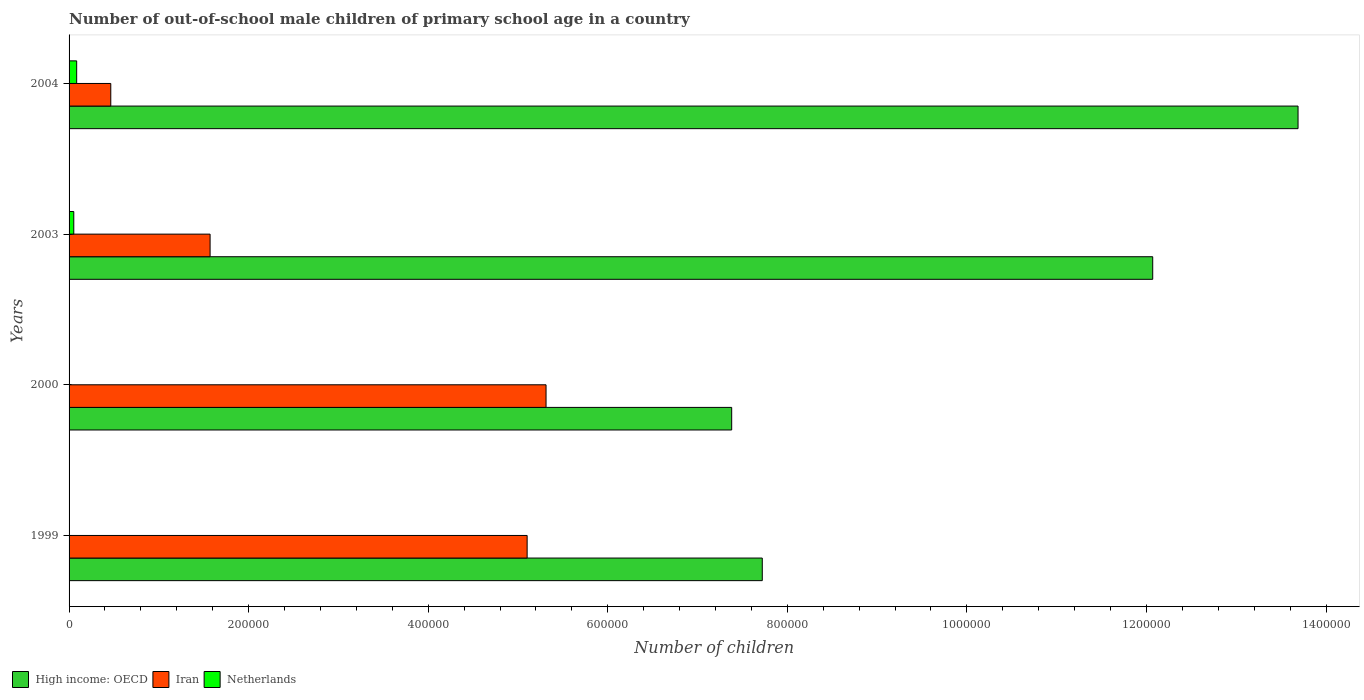How many different coloured bars are there?
Provide a succinct answer. 3. How many groups of bars are there?
Your response must be concise. 4. Are the number of bars per tick equal to the number of legend labels?
Ensure brevity in your answer.  Yes. How many bars are there on the 4th tick from the bottom?
Offer a very short reply. 3. In how many cases, is the number of bars for a given year not equal to the number of legend labels?
Make the answer very short. 0. What is the number of out-of-school male children in Iran in 2003?
Ensure brevity in your answer.  1.57e+05. Across all years, what is the maximum number of out-of-school male children in Netherlands?
Your response must be concise. 8467. What is the total number of out-of-school male children in High income: OECD in the graph?
Offer a terse response. 4.09e+06. What is the difference between the number of out-of-school male children in Netherlands in 1999 and that in 2003?
Provide a succinct answer. -5167. What is the difference between the number of out-of-school male children in High income: OECD in 2004 and the number of out-of-school male children in Iran in 2003?
Offer a terse response. 1.21e+06. What is the average number of out-of-school male children in High income: OECD per year?
Offer a very short reply. 1.02e+06. In the year 2003, what is the difference between the number of out-of-school male children in High income: OECD and number of out-of-school male children in Iran?
Offer a terse response. 1.05e+06. In how many years, is the number of out-of-school male children in Iran greater than 880000 ?
Your response must be concise. 0. What is the ratio of the number of out-of-school male children in Iran in 2000 to that in 2003?
Keep it short and to the point. 3.38. Is the difference between the number of out-of-school male children in High income: OECD in 2000 and 2003 greater than the difference between the number of out-of-school male children in Iran in 2000 and 2003?
Provide a succinct answer. No. What is the difference between the highest and the second highest number of out-of-school male children in High income: OECD?
Your answer should be very brief. 1.62e+05. What is the difference between the highest and the lowest number of out-of-school male children in Iran?
Offer a terse response. 4.85e+05. Is the sum of the number of out-of-school male children in Netherlands in 1999 and 2000 greater than the maximum number of out-of-school male children in Iran across all years?
Offer a terse response. No. What does the 1st bar from the top in 1999 represents?
Make the answer very short. Netherlands. What does the 3rd bar from the bottom in 2003 represents?
Offer a very short reply. Netherlands. Is it the case that in every year, the sum of the number of out-of-school male children in Iran and number of out-of-school male children in Netherlands is greater than the number of out-of-school male children in High income: OECD?
Your answer should be very brief. No. Are all the bars in the graph horizontal?
Your answer should be compact. Yes. Where does the legend appear in the graph?
Ensure brevity in your answer.  Bottom left. What is the title of the graph?
Give a very brief answer. Number of out-of-school male children of primary school age in a country. Does "Maldives" appear as one of the legend labels in the graph?
Keep it short and to the point. No. What is the label or title of the X-axis?
Keep it short and to the point. Number of children. What is the label or title of the Y-axis?
Your answer should be very brief. Years. What is the Number of children of High income: OECD in 1999?
Ensure brevity in your answer.  7.72e+05. What is the Number of children of Iran in 1999?
Offer a terse response. 5.10e+05. What is the Number of children of Netherlands in 1999?
Offer a terse response. 85. What is the Number of children of High income: OECD in 2000?
Keep it short and to the point. 7.38e+05. What is the Number of children of Iran in 2000?
Give a very brief answer. 5.31e+05. What is the Number of children in High income: OECD in 2003?
Ensure brevity in your answer.  1.21e+06. What is the Number of children of Iran in 2003?
Ensure brevity in your answer.  1.57e+05. What is the Number of children of Netherlands in 2003?
Your answer should be very brief. 5252. What is the Number of children in High income: OECD in 2004?
Your answer should be compact. 1.37e+06. What is the Number of children in Iran in 2004?
Your answer should be compact. 4.65e+04. What is the Number of children in Netherlands in 2004?
Provide a short and direct response. 8467. Across all years, what is the maximum Number of children of High income: OECD?
Give a very brief answer. 1.37e+06. Across all years, what is the maximum Number of children of Iran?
Provide a short and direct response. 5.31e+05. Across all years, what is the maximum Number of children of Netherlands?
Provide a short and direct response. 8467. Across all years, what is the minimum Number of children in High income: OECD?
Provide a short and direct response. 7.38e+05. Across all years, what is the minimum Number of children of Iran?
Ensure brevity in your answer.  4.65e+04. Across all years, what is the minimum Number of children of Netherlands?
Give a very brief answer. 67. What is the total Number of children in High income: OECD in the graph?
Your answer should be very brief. 4.09e+06. What is the total Number of children in Iran in the graph?
Provide a short and direct response. 1.24e+06. What is the total Number of children of Netherlands in the graph?
Provide a succinct answer. 1.39e+04. What is the difference between the Number of children in High income: OECD in 1999 and that in 2000?
Ensure brevity in your answer.  3.41e+04. What is the difference between the Number of children of Iran in 1999 and that in 2000?
Your answer should be very brief. -2.11e+04. What is the difference between the Number of children of Netherlands in 1999 and that in 2000?
Your response must be concise. 18. What is the difference between the Number of children of High income: OECD in 1999 and that in 2003?
Ensure brevity in your answer.  -4.35e+05. What is the difference between the Number of children of Iran in 1999 and that in 2003?
Offer a very short reply. 3.53e+05. What is the difference between the Number of children of Netherlands in 1999 and that in 2003?
Your response must be concise. -5167. What is the difference between the Number of children in High income: OECD in 1999 and that in 2004?
Your answer should be very brief. -5.97e+05. What is the difference between the Number of children of Iran in 1999 and that in 2004?
Keep it short and to the point. 4.64e+05. What is the difference between the Number of children of Netherlands in 1999 and that in 2004?
Keep it short and to the point. -8382. What is the difference between the Number of children in High income: OECD in 2000 and that in 2003?
Offer a terse response. -4.69e+05. What is the difference between the Number of children in Iran in 2000 and that in 2003?
Ensure brevity in your answer.  3.74e+05. What is the difference between the Number of children of Netherlands in 2000 and that in 2003?
Your response must be concise. -5185. What is the difference between the Number of children of High income: OECD in 2000 and that in 2004?
Provide a short and direct response. -6.31e+05. What is the difference between the Number of children in Iran in 2000 and that in 2004?
Keep it short and to the point. 4.85e+05. What is the difference between the Number of children in Netherlands in 2000 and that in 2004?
Your response must be concise. -8400. What is the difference between the Number of children of High income: OECD in 2003 and that in 2004?
Make the answer very short. -1.62e+05. What is the difference between the Number of children in Iran in 2003 and that in 2004?
Keep it short and to the point. 1.11e+05. What is the difference between the Number of children of Netherlands in 2003 and that in 2004?
Offer a very short reply. -3215. What is the difference between the Number of children of High income: OECD in 1999 and the Number of children of Iran in 2000?
Ensure brevity in your answer.  2.41e+05. What is the difference between the Number of children of High income: OECD in 1999 and the Number of children of Netherlands in 2000?
Offer a terse response. 7.72e+05. What is the difference between the Number of children of Iran in 1999 and the Number of children of Netherlands in 2000?
Keep it short and to the point. 5.10e+05. What is the difference between the Number of children of High income: OECD in 1999 and the Number of children of Iran in 2003?
Provide a succinct answer. 6.15e+05. What is the difference between the Number of children in High income: OECD in 1999 and the Number of children in Netherlands in 2003?
Your answer should be very brief. 7.67e+05. What is the difference between the Number of children in Iran in 1999 and the Number of children in Netherlands in 2003?
Make the answer very short. 5.05e+05. What is the difference between the Number of children in High income: OECD in 1999 and the Number of children in Iran in 2004?
Your response must be concise. 7.26e+05. What is the difference between the Number of children in High income: OECD in 1999 and the Number of children in Netherlands in 2004?
Offer a very short reply. 7.64e+05. What is the difference between the Number of children in Iran in 1999 and the Number of children in Netherlands in 2004?
Make the answer very short. 5.02e+05. What is the difference between the Number of children in High income: OECD in 2000 and the Number of children in Iran in 2003?
Your answer should be compact. 5.81e+05. What is the difference between the Number of children of High income: OECD in 2000 and the Number of children of Netherlands in 2003?
Give a very brief answer. 7.33e+05. What is the difference between the Number of children in Iran in 2000 and the Number of children in Netherlands in 2003?
Give a very brief answer. 5.26e+05. What is the difference between the Number of children in High income: OECD in 2000 and the Number of children in Iran in 2004?
Give a very brief answer. 6.92e+05. What is the difference between the Number of children in High income: OECD in 2000 and the Number of children in Netherlands in 2004?
Keep it short and to the point. 7.30e+05. What is the difference between the Number of children in Iran in 2000 and the Number of children in Netherlands in 2004?
Your response must be concise. 5.23e+05. What is the difference between the Number of children in High income: OECD in 2003 and the Number of children in Iran in 2004?
Your answer should be very brief. 1.16e+06. What is the difference between the Number of children in High income: OECD in 2003 and the Number of children in Netherlands in 2004?
Your response must be concise. 1.20e+06. What is the difference between the Number of children of Iran in 2003 and the Number of children of Netherlands in 2004?
Offer a very short reply. 1.49e+05. What is the average Number of children of High income: OECD per year?
Provide a short and direct response. 1.02e+06. What is the average Number of children of Iran per year?
Ensure brevity in your answer.  3.11e+05. What is the average Number of children in Netherlands per year?
Your answer should be very brief. 3467.75. In the year 1999, what is the difference between the Number of children in High income: OECD and Number of children in Iran?
Offer a very short reply. 2.62e+05. In the year 1999, what is the difference between the Number of children in High income: OECD and Number of children in Netherlands?
Give a very brief answer. 7.72e+05. In the year 1999, what is the difference between the Number of children in Iran and Number of children in Netherlands?
Your response must be concise. 5.10e+05. In the year 2000, what is the difference between the Number of children in High income: OECD and Number of children in Iran?
Keep it short and to the point. 2.07e+05. In the year 2000, what is the difference between the Number of children in High income: OECD and Number of children in Netherlands?
Your response must be concise. 7.38e+05. In the year 2000, what is the difference between the Number of children of Iran and Number of children of Netherlands?
Offer a terse response. 5.31e+05. In the year 2003, what is the difference between the Number of children in High income: OECD and Number of children in Iran?
Your answer should be compact. 1.05e+06. In the year 2003, what is the difference between the Number of children in High income: OECD and Number of children in Netherlands?
Your answer should be very brief. 1.20e+06. In the year 2003, what is the difference between the Number of children of Iran and Number of children of Netherlands?
Offer a terse response. 1.52e+05. In the year 2004, what is the difference between the Number of children in High income: OECD and Number of children in Iran?
Offer a terse response. 1.32e+06. In the year 2004, what is the difference between the Number of children of High income: OECD and Number of children of Netherlands?
Ensure brevity in your answer.  1.36e+06. In the year 2004, what is the difference between the Number of children in Iran and Number of children in Netherlands?
Give a very brief answer. 3.80e+04. What is the ratio of the Number of children of High income: OECD in 1999 to that in 2000?
Ensure brevity in your answer.  1.05. What is the ratio of the Number of children in Iran in 1999 to that in 2000?
Ensure brevity in your answer.  0.96. What is the ratio of the Number of children in Netherlands in 1999 to that in 2000?
Your response must be concise. 1.27. What is the ratio of the Number of children in High income: OECD in 1999 to that in 2003?
Offer a terse response. 0.64. What is the ratio of the Number of children of Iran in 1999 to that in 2003?
Make the answer very short. 3.25. What is the ratio of the Number of children of Netherlands in 1999 to that in 2003?
Offer a very short reply. 0.02. What is the ratio of the Number of children in High income: OECD in 1999 to that in 2004?
Offer a very short reply. 0.56. What is the ratio of the Number of children of Iran in 1999 to that in 2004?
Offer a terse response. 10.98. What is the ratio of the Number of children of High income: OECD in 2000 to that in 2003?
Your answer should be very brief. 0.61. What is the ratio of the Number of children in Iran in 2000 to that in 2003?
Ensure brevity in your answer.  3.38. What is the ratio of the Number of children in Netherlands in 2000 to that in 2003?
Make the answer very short. 0.01. What is the ratio of the Number of children in High income: OECD in 2000 to that in 2004?
Your answer should be compact. 0.54. What is the ratio of the Number of children in Iran in 2000 to that in 2004?
Provide a short and direct response. 11.44. What is the ratio of the Number of children in Netherlands in 2000 to that in 2004?
Your answer should be compact. 0.01. What is the ratio of the Number of children of High income: OECD in 2003 to that in 2004?
Provide a short and direct response. 0.88. What is the ratio of the Number of children in Iran in 2003 to that in 2004?
Provide a short and direct response. 3.38. What is the ratio of the Number of children of Netherlands in 2003 to that in 2004?
Provide a short and direct response. 0.62. What is the difference between the highest and the second highest Number of children of High income: OECD?
Ensure brevity in your answer.  1.62e+05. What is the difference between the highest and the second highest Number of children in Iran?
Provide a succinct answer. 2.11e+04. What is the difference between the highest and the second highest Number of children in Netherlands?
Make the answer very short. 3215. What is the difference between the highest and the lowest Number of children in High income: OECD?
Provide a succinct answer. 6.31e+05. What is the difference between the highest and the lowest Number of children in Iran?
Your answer should be very brief. 4.85e+05. What is the difference between the highest and the lowest Number of children in Netherlands?
Your answer should be very brief. 8400. 